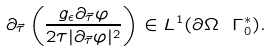Convert formula to latex. <formula><loc_0><loc_0><loc_500><loc_500>\partial _ { \vec { \tau } } \left ( \frac { g _ { \epsilon } \partial _ { \vec { \tau } } \varphi } { 2 \tau | \partial _ { \vec { \tau } } \varphi | ^ { 2 } } \right ) \in L ^ { 1 } ( \partial \Omega \ \Gamma _ { 0 } ^ { * } ) .</formula> 